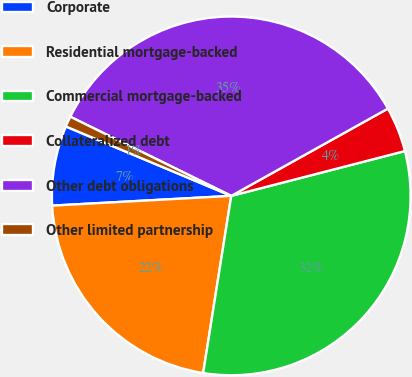Convert chart. <chart><loc_0><loc_0><loc_500><loc_500><pie_chart><fcel>Corporate<fcel>Residential mortgage-backed<fcel>Commercial mortgage-backed<fcel>Collateralized debt<fcel>Other debt obligations<fcel>Other limited partnership<nl><fcel>7.19%<fcel>21.63%<fcel>31.52%<fcel>4.07%<fcel>34.63%<fcel>0.95%<nl></chart> 